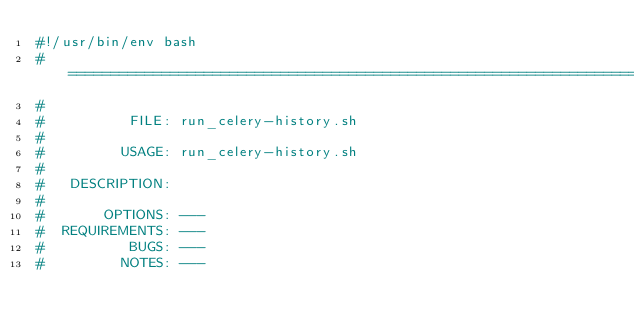<code> <loc_0><loc_0><loc_500><loc_500><_Bash_>#!/usr/bin/env bash
#===============================================================================
#
#          FILE: run_celery-history.sh
#
#         USAGE: run_celery-history.sh
#
#   DESCRIPTION: 
#
#       OPTIONS: ---
#  REQUIREMENTS: ---
#          BUGS: ---
#         NOTES: ---</code> 